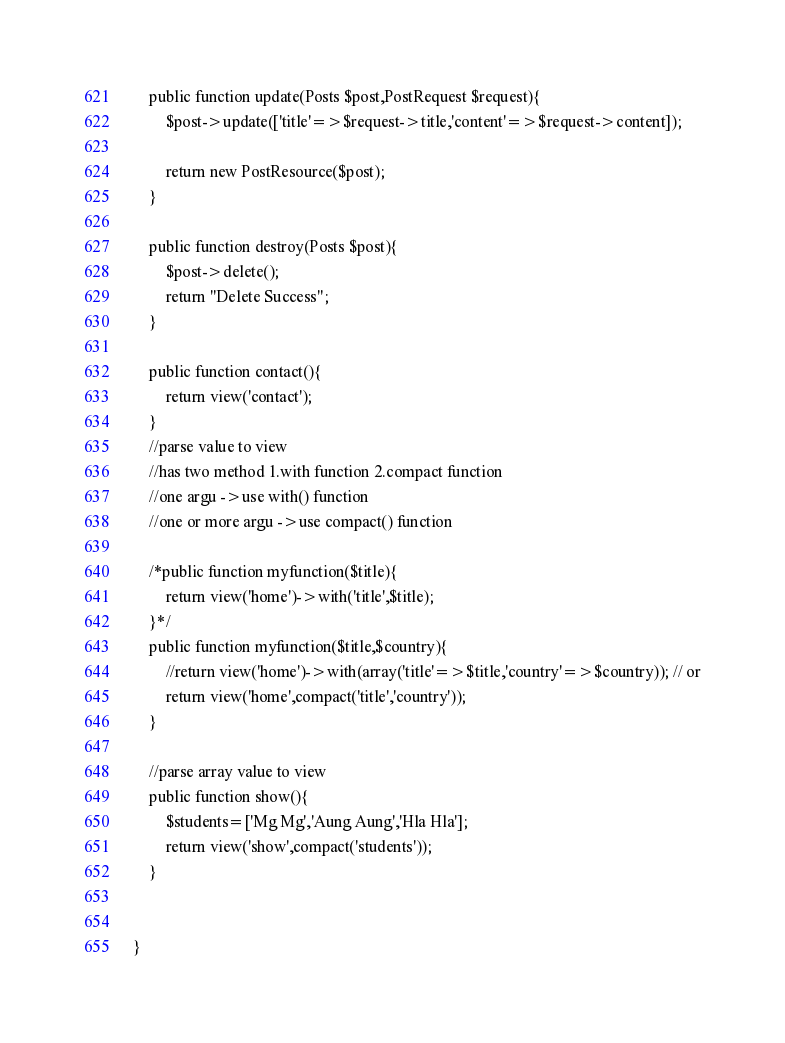Convert code to text. <code><loc_0><loc_0><loc_500><loc_500><_PHP_>
    public function update(Posts $post,PostRequest $request){
        $post->update(['title'=>$request->title,'content'=>$request->content]);

        return new PostResource($post);
    }

    public function destroy(Posts $post){
        $post->delete();
        return "Delete Success";
    }

    public function contact(){
        return view('contact');
    }
    //parse value to view
    //has two method 1.with function 2.compact function
    //one argu ->use with() function
    //one or more argu ->use compact() function

    /*public function myfunction($title){
        return view('home')->with('title',$title);
    }*/
    public function myfunction($title,$country){
        //return view('home')->with(array('title'=>$title,'country'=>$country)); // or
        return view('home',compact('title','country'));
    }

    //parse array value to view
    public function show(){
        $students=['Mg Mg','Aung Aung','Hla Hla'];
        return view('show',compact('students'));
    }


}
</code> 